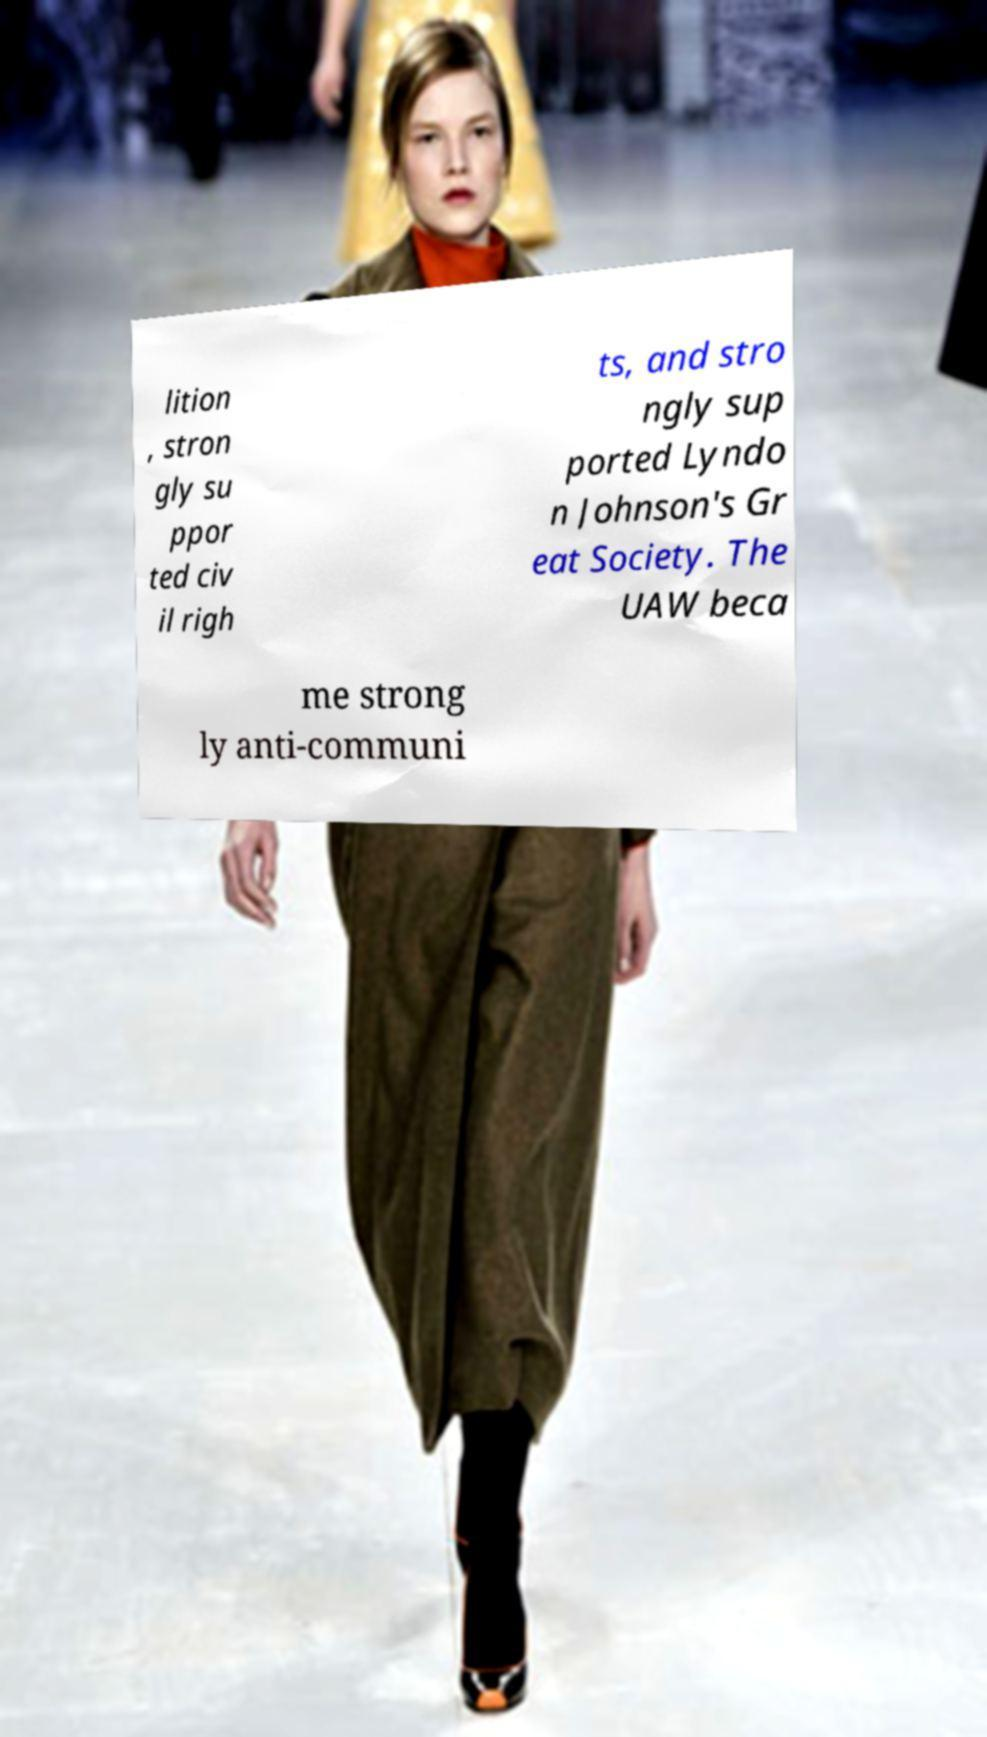Can you accurately transcribe the text from the provided image for me? lition , stron gly su ppor ted civ il righ ts, and stro ngly sup ported Lyndo n Johnson's Gr eat Society. The UAW beca me strong ly anti-communi 